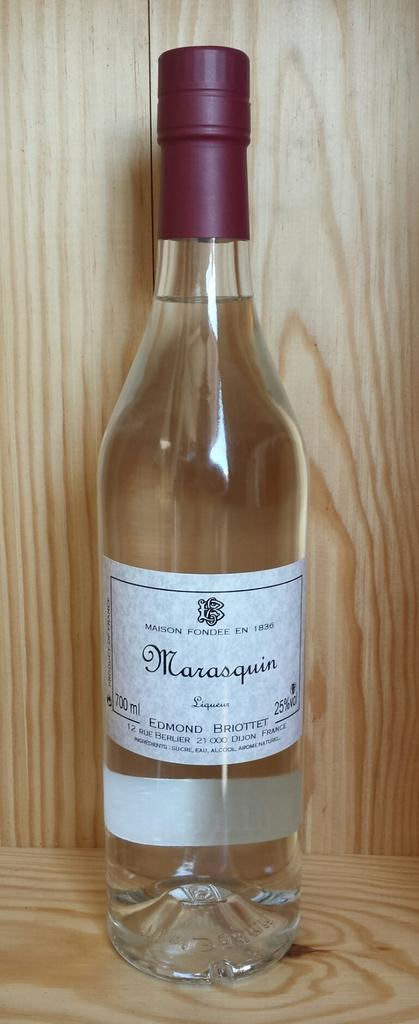What type of bottle is visible in the image? There is a white glass bottle in the image. What is written on the bottle? The bottle is named MARASQUIN. How is the bottle stored in the image? The bottle is kept in a brown wooden box. What type of glove is being used to make a decision in the image? There is no glove or decision-making process depicted in the image. 